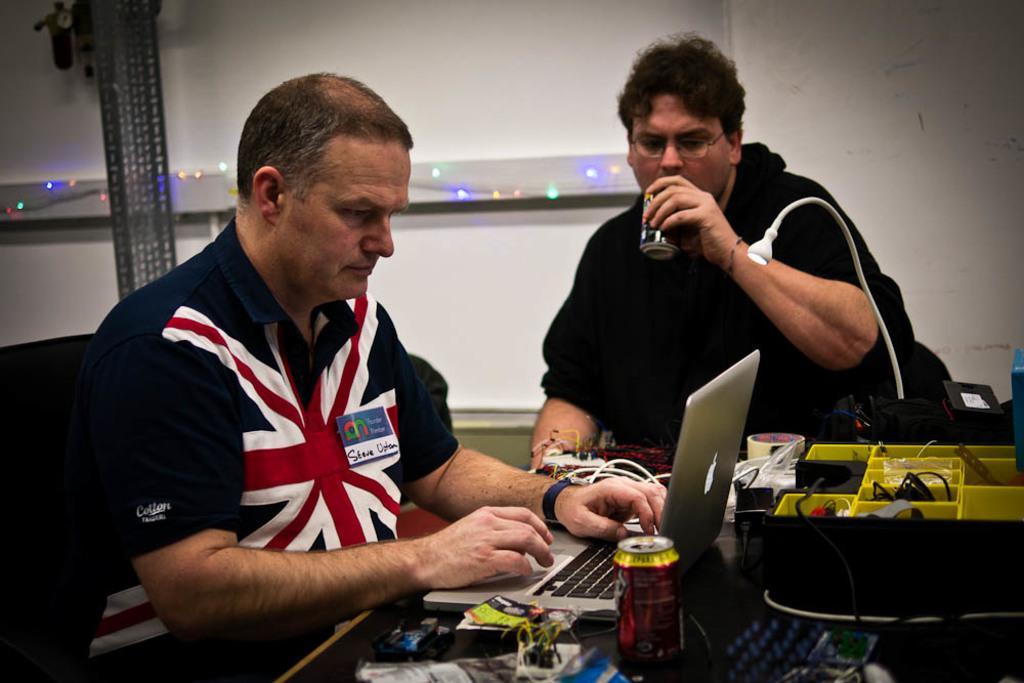In one or two sentences, can you explain what this image depicts? In this image there are two persons are sitting as we can see in middle of this image, there is a table at bottom right corner of this image there is a laptop and some other objects are kept on it , and there is a glass door is in the background. There is a chair at left side of this image and the person sitting at right side of this image is holding a drink. 